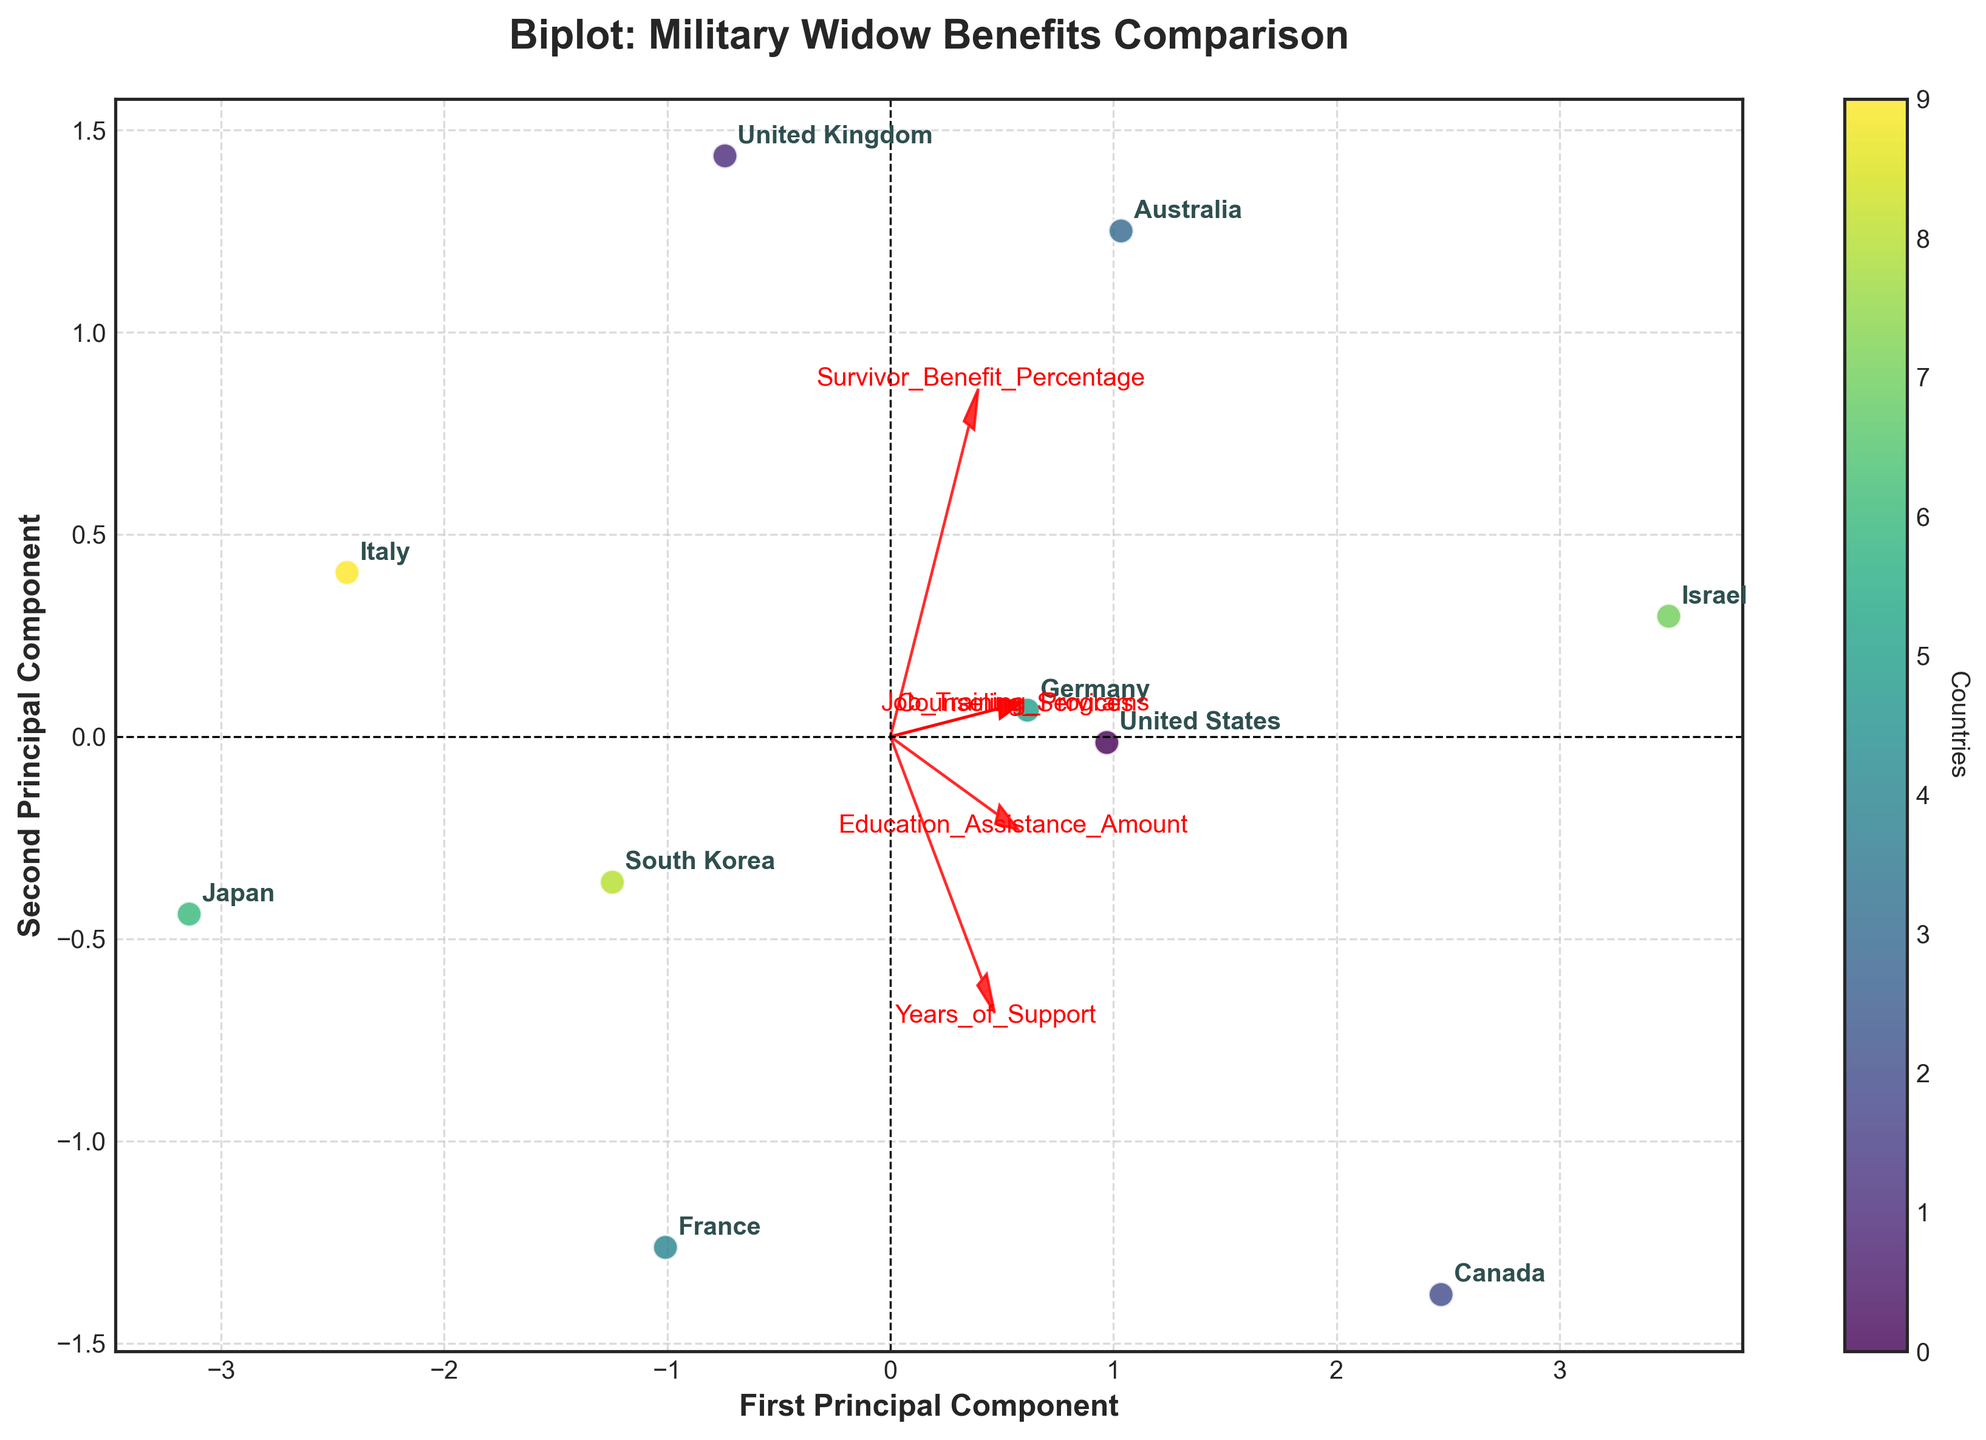How many countries are represented in the biplot? The color bar indicates the number of distinct data points, and labels are visible for each data point. Count the annotated country names to determine the unique countries.
Answer: 10 Which country has the highest Survivor Benefit Percentage according to the biplot? Look for the data point label corresponding to the highest position along the survivor benefit feature vector (red arrow for Survivor Benefit Percentage). The highest position on this vector will indicate the maximum Survivor Benefit Percentage.
Answer: Israel Which country offers the least amount of Education Assistance? Education Assistance can be determined by the orientation corresponding to the 'Education_Assistance_Amount' feature vector. Identify the data point farthest in the opposite direction of this vector for the least amount.
Answer: Japan Which two countries provide the longest years of support? The feature 'Years_of_Support' will be indicated by a red arrow on the biplot. Identify the two annotated country data points that are the longest along this feature vector, indicating maximum values.
Answer: Canada, Israel Do Japan and South Korea offer similar levels of Survivor Benefits? Compare the data points annotated as 'Japan' and 'South Korea' along the direction of the 'Survivor_Benefit_Percentage' feature vector. Determine whether they are close in magnitude.
Answer: No Which country stands out for offering both substantial Counseling Services and Job Training Programs? Locate the 'Counseling_Services' and 'Job_Training_Programs' feature vectors. Identify the data point annotated with a country label that is near the ends of both vectors, indicating high values for both features.
Answer: Canada Are the countries in Europe generally grouped together or spread out in the biplot visualization? Assess the spatial distribution of the European countries' data points (United Kingdom, France, Germany, Italy). See whether these points are close together or dispersed across the plot.
Answer: Spread out Which country has the greatest divergence from Japan in terms of benefit features? Find the data point farthest from 'Japan' across all principal components in the biplot to determine the country with the greatest divergence in feature metrics.
Answer: Israel Do Australia and the United States provide comparable levels of support across most benefits? Examine the positions of 'Australia' and 'United States' on the biplot to see if they are relatively close to each other, indicating similarity in the features.
Answer: Yes 